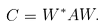<formula> <loc_0><loc_0><loc_500><loc_500>C = W ^ { * } A W .</formula> 